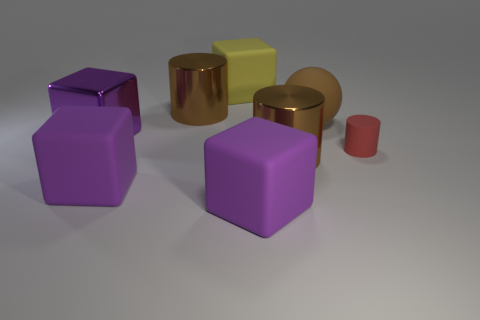Are there any other things that are the same size as the red matte cylinder?
Offer a terse response. No. Is there anything else that has the same shape as the large brown matte object?
Provide a succinct answer. No. How many big objects are either brown rubber spheres or purple matte things?
Offer a very short reply. 3. Is there another thing that has the same shape as the small rubber object?
Make the answer very short. Yes. Do the purple metal thing and the large yellow matte thing have the same shape?
Keep it short and to the point. Yes. What color is the big cylinder that is on the right side of the big matte cube that is behind the large brown matte sphere?
Give a very brief answer. Brown. There is a shiny block that is the same size as the matte sphere; what is its color?
Provide a short and direct response. Purple. What number of rubber things are large brown blocks or big brown cylinders?
Your response must be concise. 0. How many large rubber objects are on the right side of the brown metal object in front of the big brown ball?
Make the answer very short. 1. What number of things are large balls or matte objects that are on the left side of the big ball?
Provide a short and direct response. 4. 